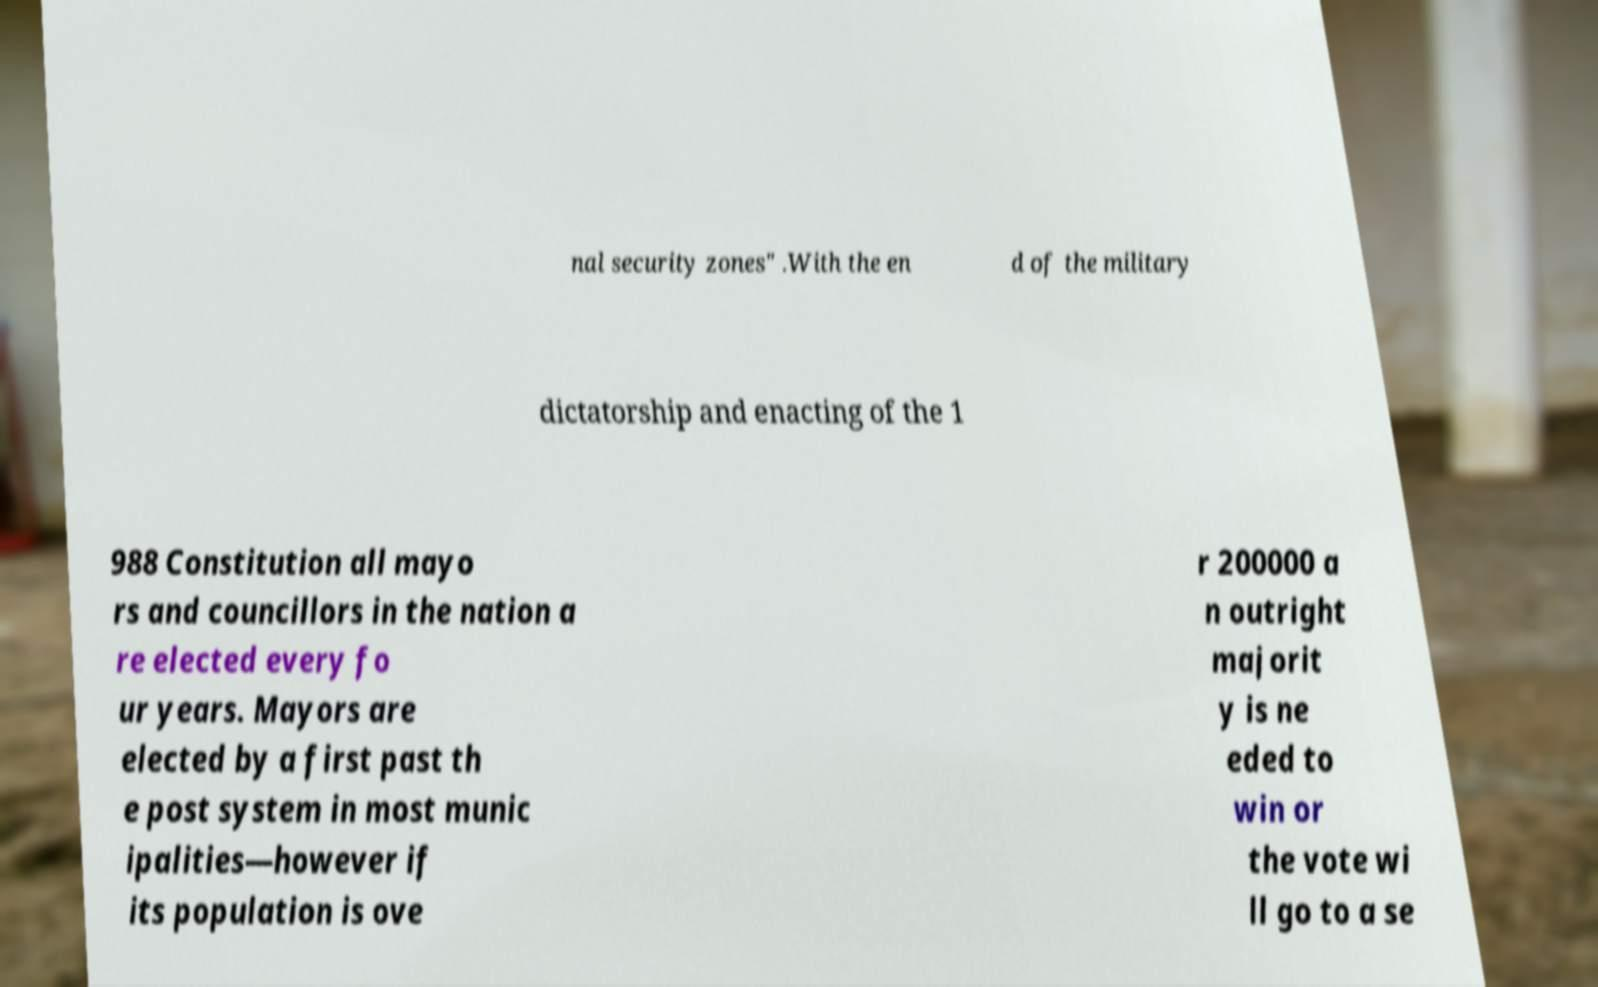I need the written content from this picture converted into text. Can you do that? nal security zones" .With the en d of the military dictatorship and enacting of the 1 988 Constitution all mayo rs and councillors in the nation a re elected every fo ur years. Mayors are elected by a first past th e post system in most munic ipalities—however if its population is ove r 200000 a n outright majorit y is ne eded to win or the vote wi ll go to a se 